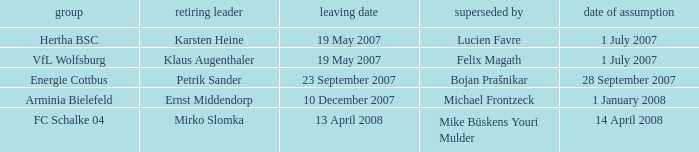When is the appointment date for outgoing manager Petrik Sander? 28 September 2007. 